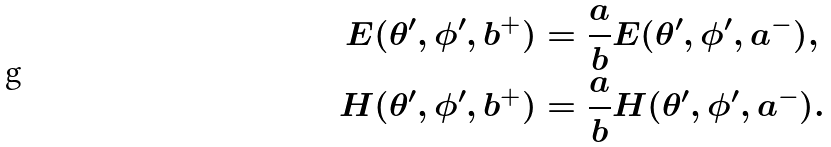<formula> <loc_0><loc_0><loc_500><loc_500>E ( \theta ^ { \prime } , \phi ^ { \prime } , b ^ { + } ) & = \frac { a } { b } E ( \theta ^ { \prime } , \phi ^ { \prime } , a ^ { - } ) , \\ H ( \theta ^ { \prime } , \phi ^ { \prime } , b ^ { + } ) & = \frac { a } { b } H ( \theta ^ { \prime } , \phi ^ { \prime } , a ^ { - } ) .</formula> 